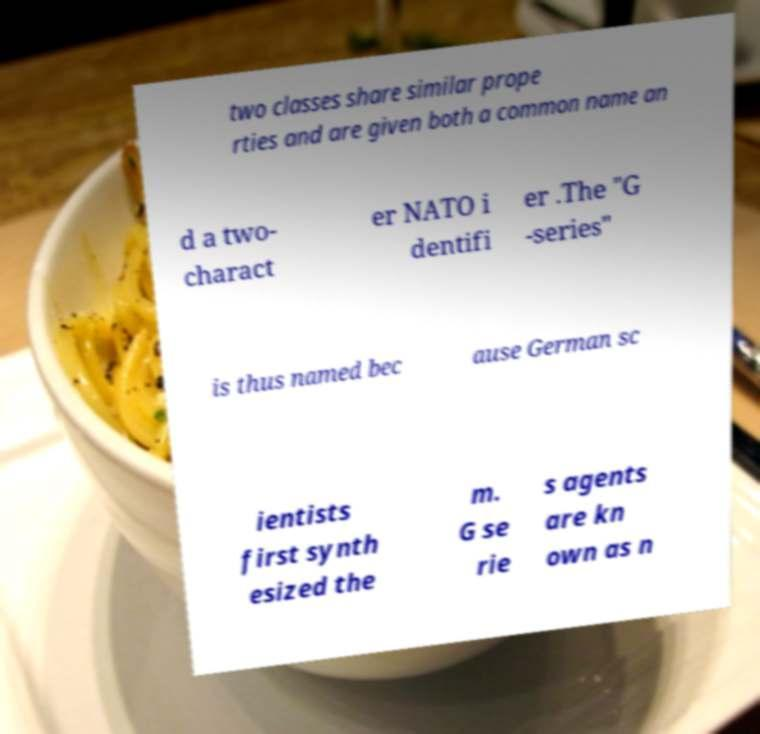Please identify and transcribe the text found in this image. two classes share similar prope rties and are given both a common name an d a two- charact er NATO i dentifi er .The "G -series" is thus named bec ause German sc ientists first synth esized the m. G se rie s agents are kn own as n 